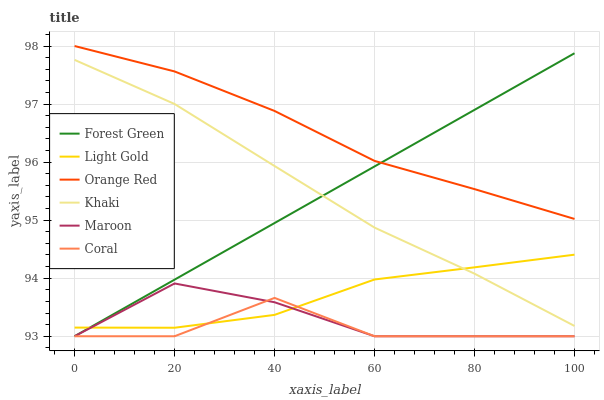Does Maroon have the minimum area under the curve?
Answer yes or no. No. Does Maroon have the maximum area under the curve?
Answer yes or no. No. Is Maroon the smoothest?
Answer yes or no. No. Is Maroon the roughest?
Answer yes or no. No. Does Light Gold have the lowest value?
Answer yes or no. No. Does Maroon have the highest value?
Answer yes or no. No. Is Coral less than Orange Red?
Answer yes or no. Yes. Is Orange Red greater than Coral?
Answer yes or no. Yes. Does Coral intersect Orange Red?
Answer yes or no. No. 